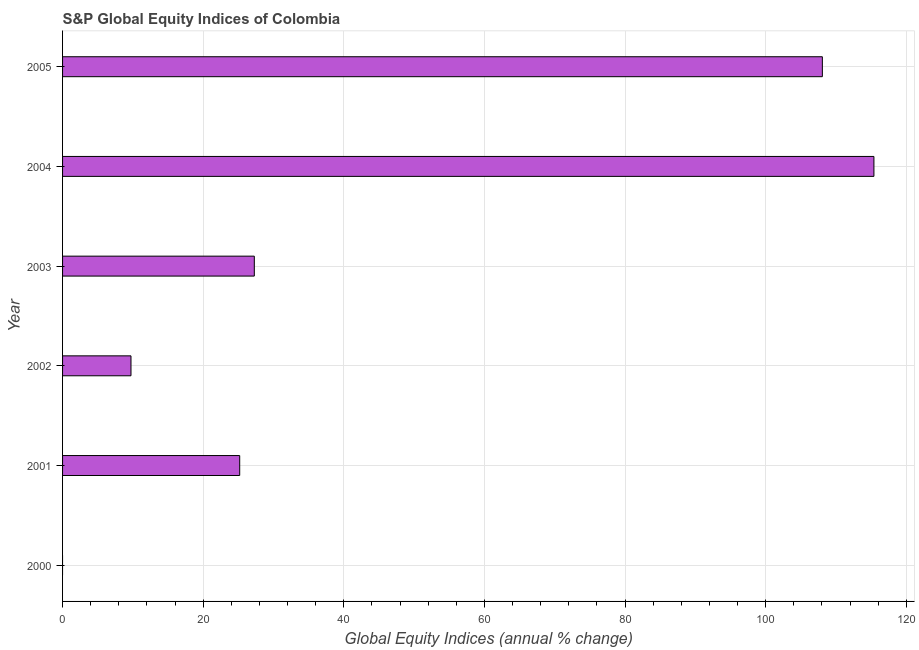What is the title of the graph?
Provide a succinct answer. S&P Global Equity Indices of Colombia. What is the label or title of the X-axis?
Offer a terse response. Global Equity Indices (annual % change). What is the s&p global equity indices in 2000?
Provide a succinct answer. 0. Across all years, what is the maximum s&p global equity indices?
Provide a succinct answer. 115.39. What is the sum of the s&p global equity indices?
Keep it short and to the point. 285.64. What is the difference between the s&p global equity indices in 2002 and 2004?
Your answer should be compact. -105.66. What is the average s&p global equity indices per year?
Provide a succinct answer. 47.61. What is the median s&p global equity indices?
Offer a terse response. 26.23. In how many years, is the s&p global equity indices greater than 72 %?
Keep it short and to the point. 2. What is the ratio of the s&p global equity indices in 2001 to that in 2004?
Provide a succinct answer. 0.22. What is the difference between the highest and the second highest s&p global equity indices?
Your response must be concise. 7.33. Is the sum of the s&p global equity indices in 2001 and 2005 greater than the maximum s&p global equity indices across all years?
Your answer should be compact. Yes. What is the difference between the highest and the lowest s&p global equity indices?
Ensure brevity in your answer.  115.39. How many bars are there?
Ensure brevity in your answer.  5. Are all the bars in the graph horizontal?
Provide a succinct answer. Yes. How many years are there in the graph?
Keep it short and to the point. 6. What is the Global Equity Indices (annual % change) in 2000?
Your response must be concise. 0. What is the Global Equity Indices (annual % change) in 2001?
Your answer should be compact. 25.19. What is the Global Equity Indices (annual % change) of 2002?
Provide a succinct answer. 9.73. What is the Global Equity Indices (annual % change) in 2003?
Your response must be concise. 27.27. What is the Global Equity Indices (annual % change) of 2004?
Offer a very short reply. 115.39. What is the Global Equity Indices (annual % change) of 2005?
Provide a short and direct response. 108.06. What is the difference between the Global Equity Indices (annual % change) in 2001 and 2002?
Your answer should be compact. 15.46. What is the difference between the Global Equity Indices (annual % change) in 2001 and 2003?
Provide a short and direct response. -2.08. What is the difference between the Global Equity Indices (annual % change) in 2001 and 2004?
Offer a very short reply. -90.2. What is the difference between the Global Equity Indices (annual % change) in 2001 and 2005?
Offer a terse response. -82.86. What is the difference between the Global Equity Indices (annual % change) in 2002 and 2003?
Provide a succinct answer. -17.54. What is the difference between the Global Equity Indices (annual % change) in 2002 and 2004?
Offer a terse response. -105.66. What is the difference between the Global Equity Indices (annual % change) in 2002 and 2005?
Ensure brevity in your answer.  -98.33. What is the difference between the Global Equity Indices (annual % change) in 2003 and 2004?
Offer a terse response. -88.12. What is the difference between the Global Equity Indices (annual % change) in 2003 and 2005?
Keep it short and to the point. -80.79. What is the difference between the Global Equity Indices (annual % change) in 2004 and 2005?
Provide a short and direct response. 7.33. What is the ratio of the Global Equity Indices (annual % change) in 2001 to that in 2002?
Provide a short and direct response. 2.59. What is the ratio of the Global Equity Indices (annual % change) in 2001 to that in 2003?
Your answer should be compact. 0.92. What is the ratio of the Global Equity Indices (annual % change) in 2001 to that in 2004?
Provide a succinct answer. 0.22. What is the ratio of the Global Equity Indices (annual % change) in 2001 to that in 2005?
Provide a succinct answer. 0.23. What is the ratio of the Global Equity Indices (annual % change) in 2002 to that in 2003?
Give a very brief answer. 0.36. What is the ratio of the Global Equity Indices (annual % change) in 2002 to that in 2004?
Keep it short and to the point. 0.08. What is the ratio of the Global Equity Indices (annual % change) in 2002 to that in 2005?
Provide a short and direct response. 0.09. What is the ratio of the Global Equity Indices (annual % change) in 2003 to that in 2004?
Ensure brevity in your answer.  0.24. What is the ratio of the Global Equity Indices (annual % change) in 2003 to that in 2005?
Ensure brevity in your answer.  0.25. What is the ratio of the Global Equity Indices (annual % change) in 2004 to that in 2005?
Provide a succinct answer. 1.07. 